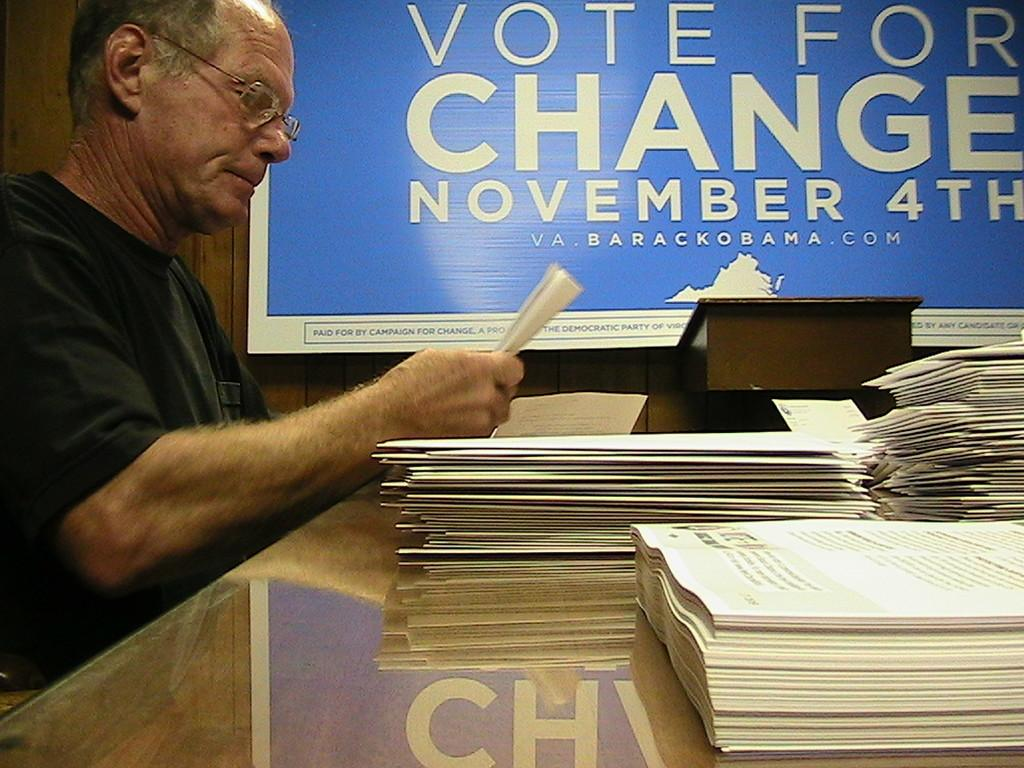<image>
Summarize the visual content of the image. A man reads papers in front of a large sign saying Vote for Change. 